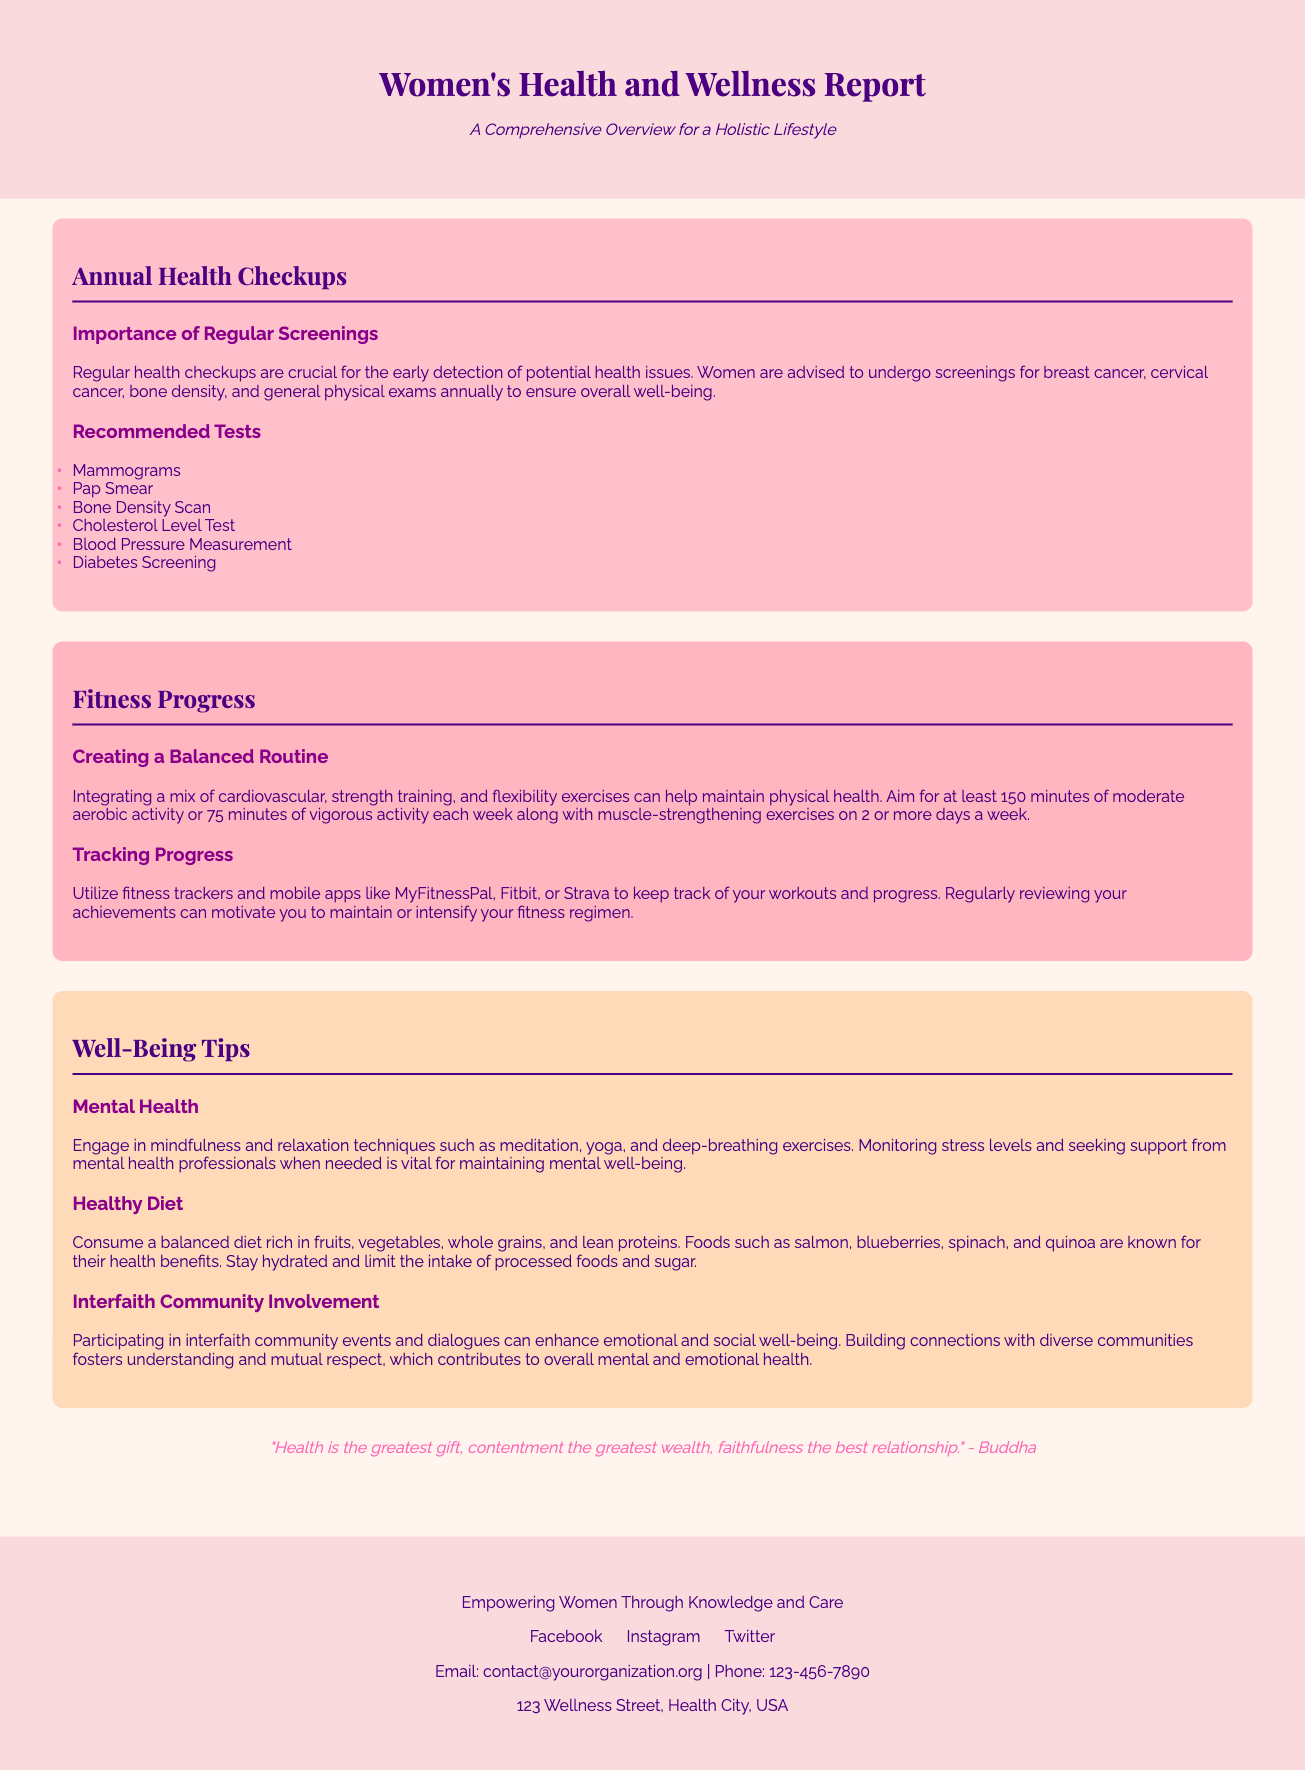what is the title of the report? The title is located at the top of the document, prominently displayed.
Answer: Women's Health and Wellness Report how many recommended tests are listed? The document lists several tests under the "Recommended Tests" section.
Answer: 6 what is one of the mental health practices mentioned? This question refers to the subsection regarding mental health in the wellness tips.
Answer: meditation what color is the background of the header? The header background color is specified in the styling of the document.
Answer: #FADADD which exercise app is mentioned for tracking progress? The document refers to specific apps in the "Tracking Progress" subsection.
Answer: MyFitnessPal what is the significance of interfaith community involvement? This question requires understanding the connection between community involvement and mental well-being.
Answer: enhances emotional and social well-being what type of diet is recommended? The recommended diet can be found in the subheading focused on nutrition in the wellness tips.
Answer: balanced diet how many minutes of aerobic activity is recommended weekly? The document specifies a duration of activity within the fitness progress section.
Answer: 150 minutes 